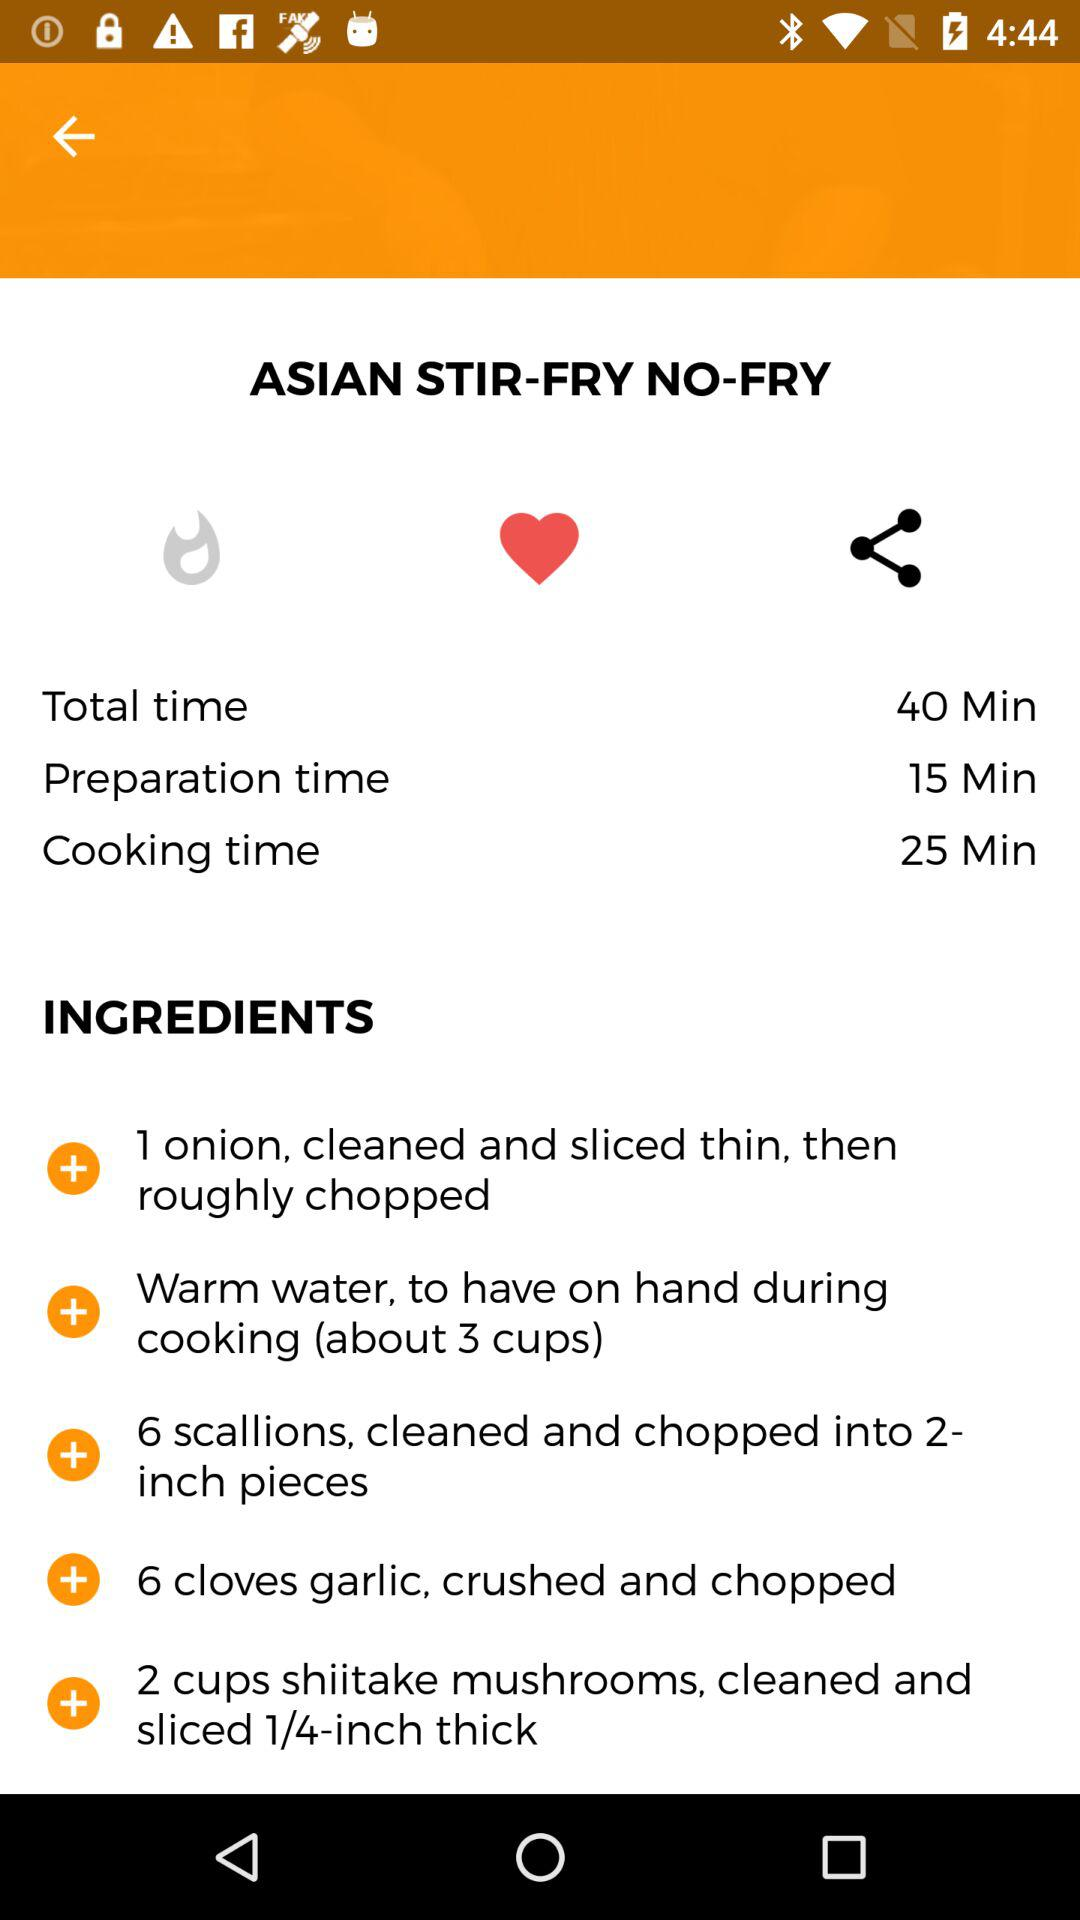How much onion is required? There is 1 onion required. 